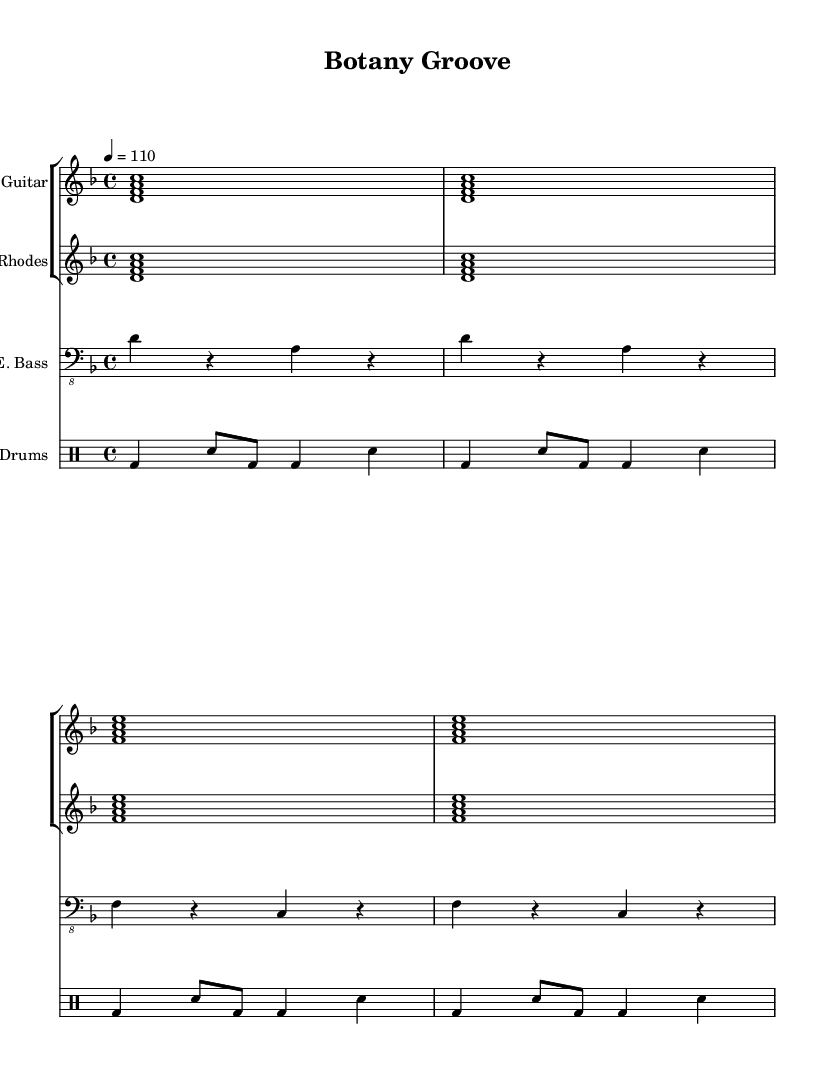What is the key signature of this music? The key signature indicated is D minor, which has one flat (B flat). This can be concluded by looking for the key signature section in the sheet music, which shows the presence of one flat.
Answer: D minor What is the time signature of this music? The time signature shown in the sheet music is 4/4, meaning there are four beats in each measure, and the quarter note gets one beat. This is typically indicated at the beginning of the score, directly following the key signature.
Answer: 4/4 What is the tempo marking for this piece? The tempo marking indicates a speed of 110 beats per minute. This is found in the tempo indication part of the score, which specifies the desired pace of the music.
Answer: 110 How many measures are there in the entire piece? Counting visually, there appear to be 8 measures in total across the parts, as each staff continues adding measures from the beginning to the end, totaling up to eight distinct sections.
Answer: 8 What is the main instrument group featured in this score? The main instruments featured in this score are electric guitar, Rhodes piano, electric bass, and drums. These classifications can be seen in the staff grouping at the start of the score where each part is labeled.
Answer: E. Guitar, Rhodes, E. Bass, Drums Does the electric guitar part contain any rests? Yes, the electric guitar part does not have any instances of rests; it is continuous across the measures presented. This can be observed by checking the sequence in the staff where notes are present without breaks.
Answer: No 